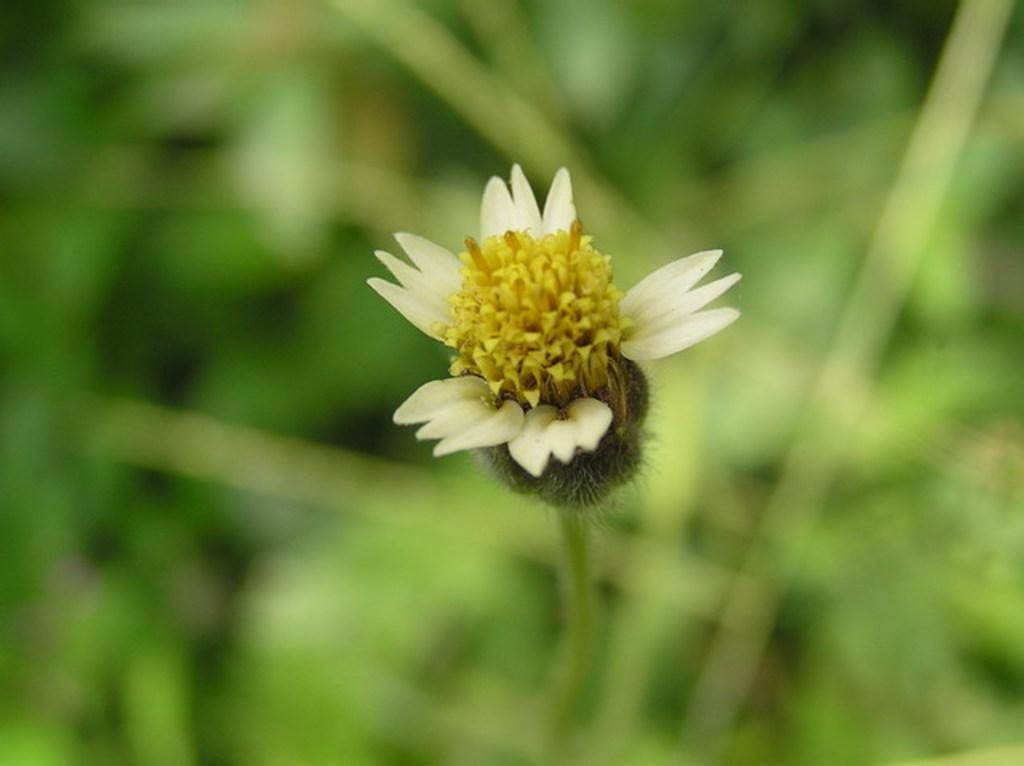Please provide a concise description of this image. In this image we can see a flower with blur background. 